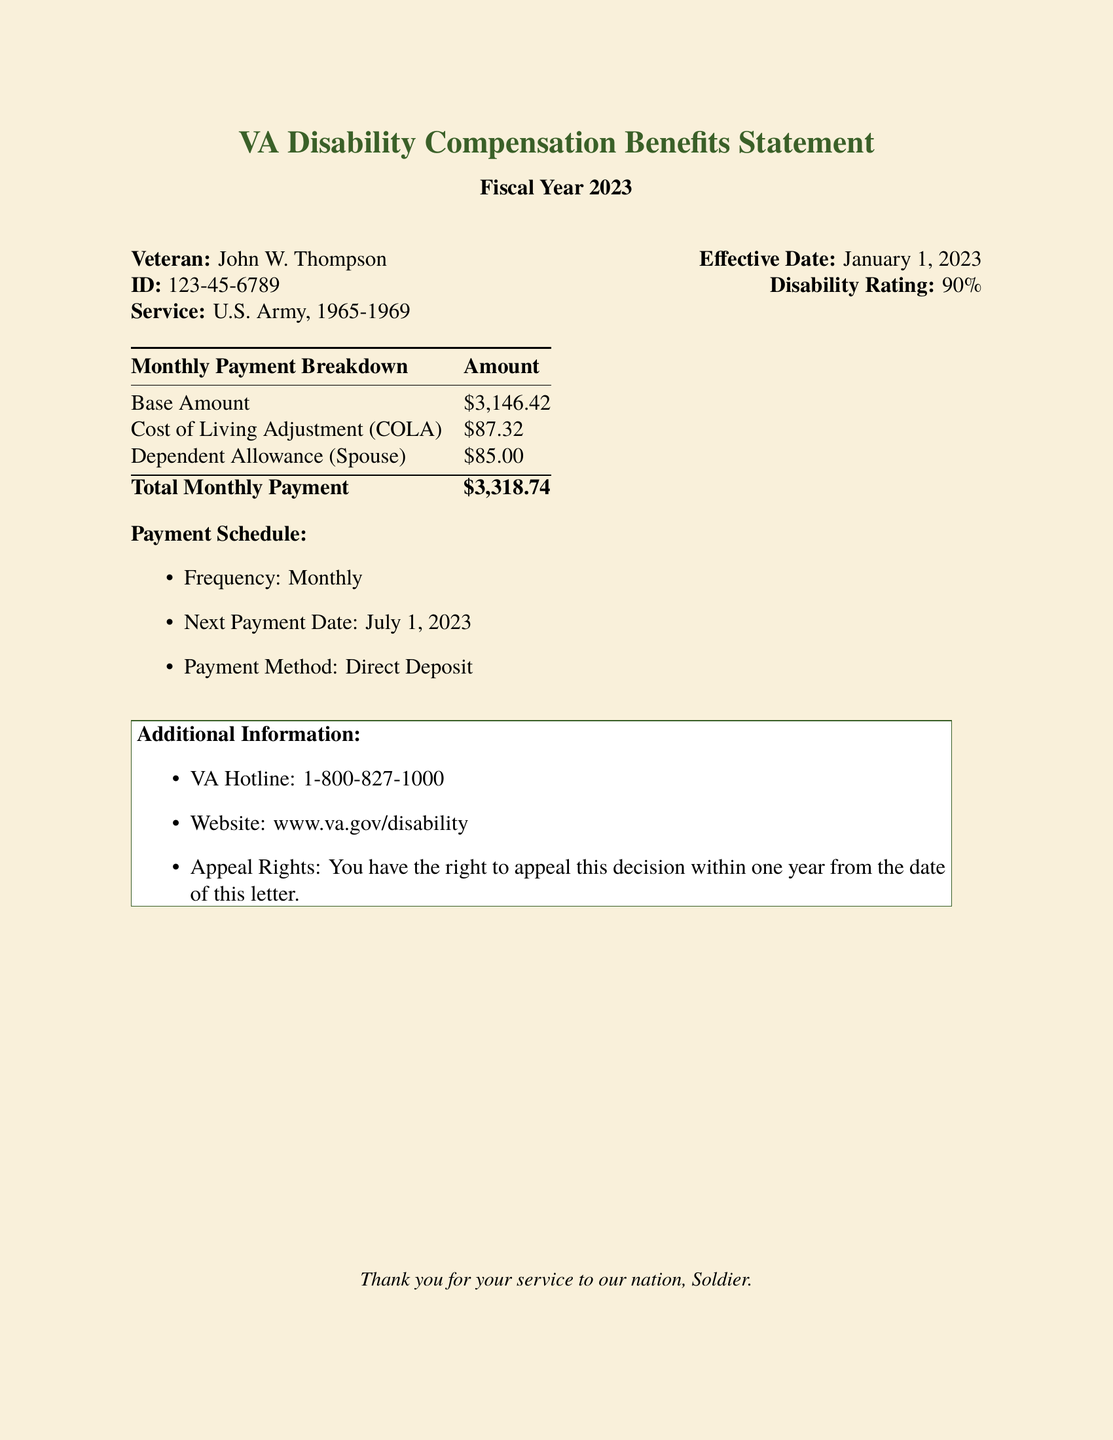what is the veteran's name? The veteran's name is displayed prominently at the beginning of the document.
Answer: John W. Thompson what is the veteran's identification number? The identification number is provided in the header section of the document.
Answer: 123-45-6789 what is the monthly base amount for compensation? The monthly base amount is stated in the payment breakdown section of the document.
Answer: $3,146.42 when is the next payment date? The next payment date is listed under the payment schedule section of the document.
Answer: July 1, 2023 what is the total monthly payment? The total monthly payment is provided at the bottom of the payment breakdown table.
Answer: $3,318.74 what percentage is the disability rating? The disability rating is mentioned next to the effective date in the header of the document.
Answer: 90% what organization is responsible for the benefits? The organization is implied by the title of the document.
Answer: VA how often are payments made? The frequency of the payments is mentioned in the payment schedule section.
Answer: Monthly what is the website for more information? The website is provided in the additional information section of the document.
Answer: www.va.gov/disability 